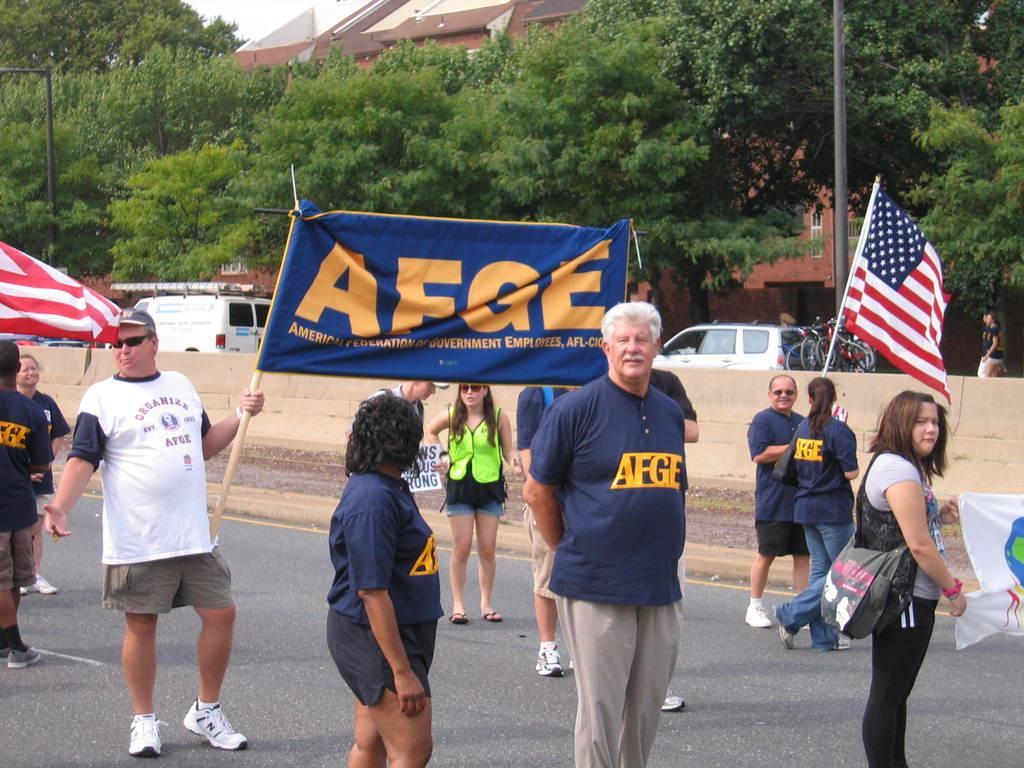Could you give a brief overview of what you see in this image? In this image I can see group of people standing and I can also see few flags, banners. In the background I can see few vehicles, trees in green color, few buildings and the sky is in white color. 